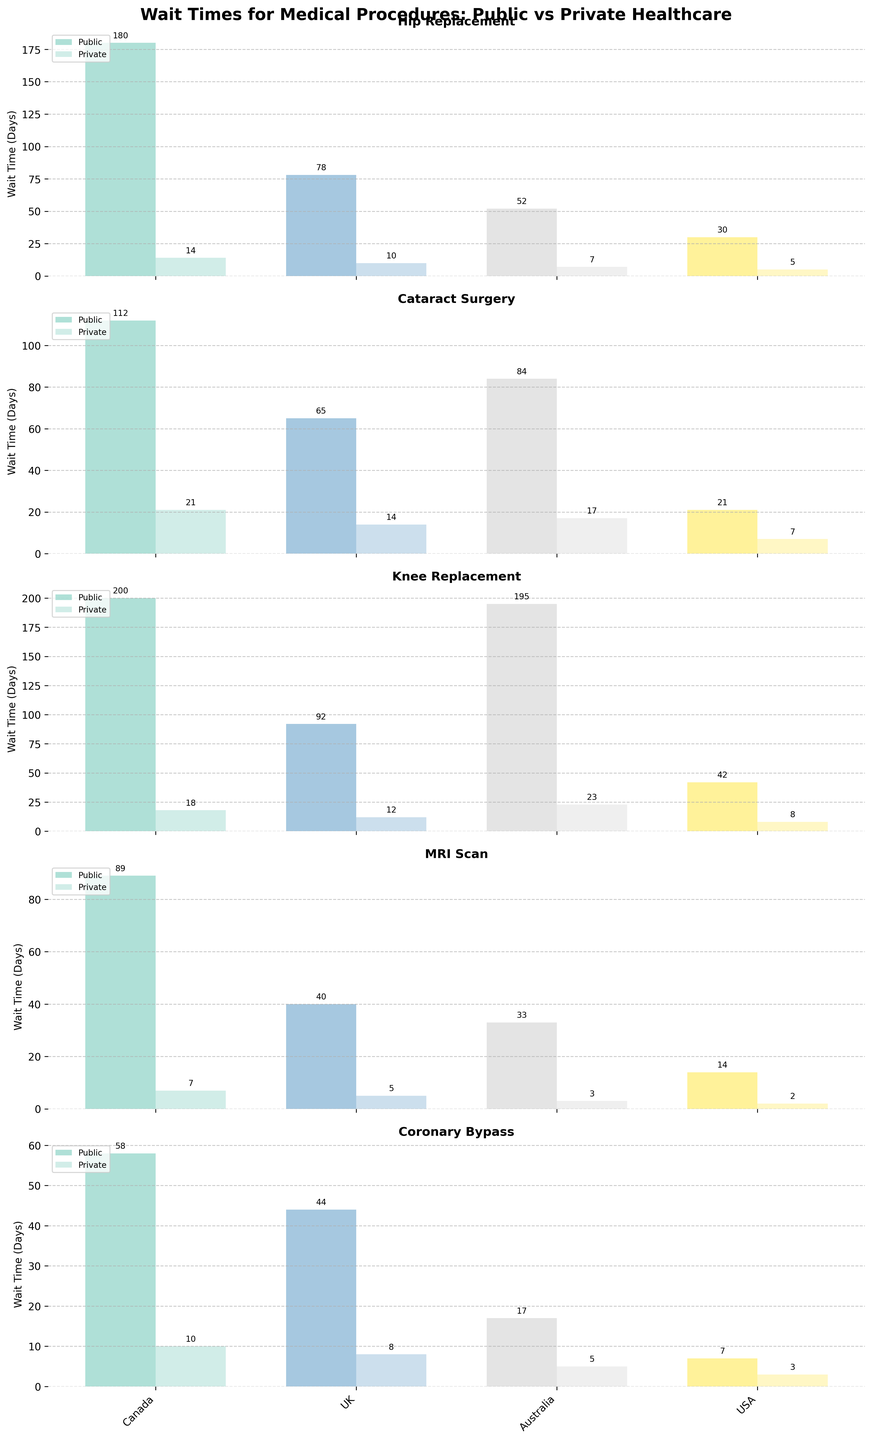Which country has the largest difference in wait times between public and private healthcare for hip replacement procedures? To determine the answer, look at the wait times for hip replacement in both public and private sectors for each country. Subtract the private wait time from the public wait time for each country. The differences are: Canada (180 - 14 = 166), UK (78 - 10 = 68), Australia (52 - 7 = 45), USA (30 - 5 = 25). The largest difference is in Canada.
Answer: Canada Which procedure has the smallest average wait time in public healthcare across all countries? Calculate the average wait time for each procedure in public healthcare by summing the wait times and dividing by the number of countries. The averages are: Hip Replacement ((180 + 78 + 52 + 30) / 4 = 85), Cataract Surgery ((112 + 65 + 84 + 21) / 4 = 70.5), Knee Replacement ((200 + 92 + 195 + 42) / 4 = 132.25), MRI Scan ((89 + 40 + 33 + 14) / 4 = 44), Coronary Bypass ((58 + 44 + 17 + 7) / 4 = 31.5). The smallest average wait time is for Coronary Bypass.
Answer: Coronary Bypass In which country does the public healthcare system perform better (shorter wait times) for MRI scans compared to private healthcare systems in other countries? Compare the public healthcare wait time for MRI scans in each country to the private healthcare wait times in other countries. Public MRI wait times are: Canada (89), UK (40), Australia (33), USA (14). Private MRI wait times in other countries are: Canada (7), UK (5), Australia (3), USA (2). The USA public wait time of 14 is shorter than private wait times in Canada (7), the UK (5), and Australia (3).
Answer: USA What is the ratio of public to private wait times for cataract surgery in Australia? To find the ratio, divide the public wait time by the private wait time for cataract surgery in Australia. The public wait time is 84 days and the private wait time is 17 days. The ratio is 84 / 17.
Answer: 4.94 Which procedure has the greatest variance in wait times between public and private healthcare across all countries? Calculate the variance for each procedure's public and private wait times across countries. The differences are: Hip Replacement (166, 68, 45, 25), Cataract Surgery (91, 51, 67, 14), Knee Replacement (182, 80, 172, 34), MRI Scan (82, 35, 30, 12), Coronary Bypass (48, 36, 12, 4). The greatest variance is for Knee Replacement, as reflected in the largest spread of differences.
Answer: Knee Replacement 